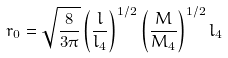<formula> <loc_0><loc_0><loc_500><loc_500>r _ { 0 } = \sqrt { \frac { 8 } { 3 \pi } } \left ( \frac { l } { l _ { 4 } } \right ) ^ { 1 / 2 } \left ( \frac { M } { M _ { 4 } } \right ) ^ { 1 / 2 } l _ { 4 }</formula> 